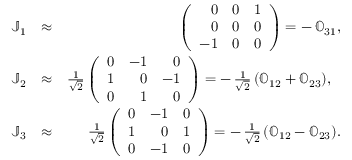<formula> <loc_0><loc_0><loc_500><loc_500>\begin{array} { r l r } { \mathbb { J } _ { 1 } } & { \approx } & { \left ( \begin{array} { r r r } { 0 } & { 0 } & { 1 } \\ { 0 } & { 0 } & { 0 } \\ { - 1 } & { 0 } & { 0 } \end{array} \right ) = - \, \mathbb { O } _ { 3 1 } , } \\ { \mathbb { J } _ { 2 } } & { \approx } & { \frac { 1 } { \sqrt { 2 } } \left ( \begin{array} { r r r } { 0 } & { - 1 } & { 0 } \\ { 1 } & { 0 } & { - 1 } \\ { 0 } & { 1 } & { 0 } \end{array} \right ) = - \, \frac { 1 } { \sqrt { 2 } } \, ( \mathbb { O } _ { 1 2 } + \mathbb { O } _ { 2 3 } ) , } \\ { \mathbb { J } _ { 3 } } & { \approx } & { \frac { 1 } { \sqrt { 2 } } \left ( \begin{array} { r r r } { 0 } & { - 1 } & { 0 } \\ { 1 } & { 0 } & { 1 } \\ { 0 } & { - 1 } & { 0 } \end{array} \right ) = - \, \frac { 1 } { \sqrt { 2 } } \, ( \mathbb { O } _ { 1 2 } - \mathbb { O } _ { 2 3 } ) . } \end{array}</formula> 